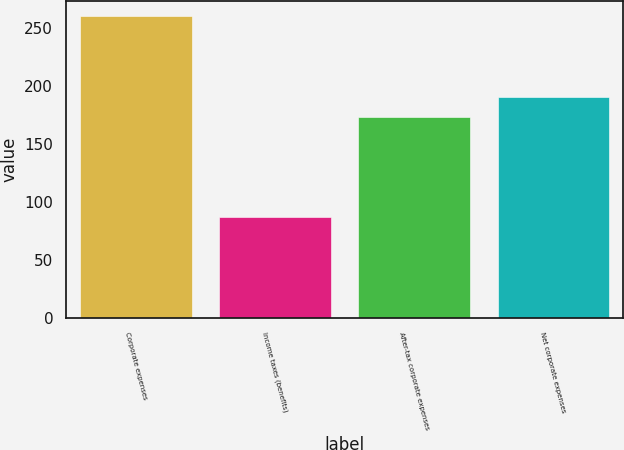Convert chart. <chart><loc_0><loc_0><loc_500><loc_500><bar_chart><fcel>Corporate expenses<fcel>Income taxes (benefits)<fcel>After-tax corporate expenses<fcel>Net corporate expenses<nl><fcel>260<fcel>87<fcel>173<fcel>190.3<nl></chart> 